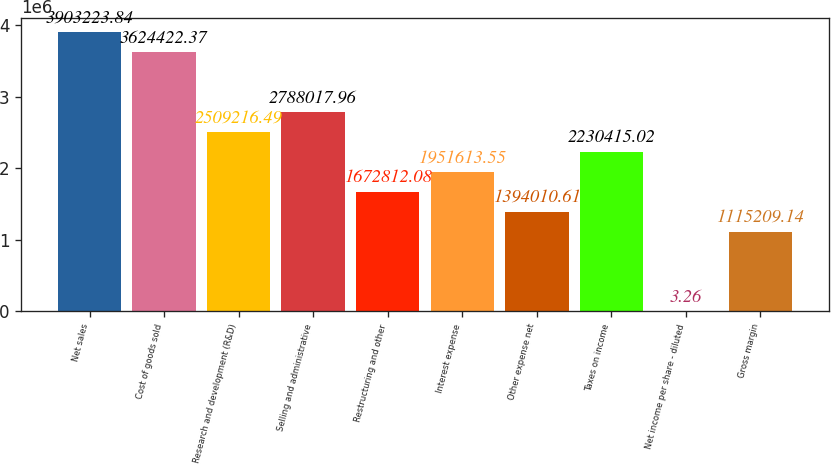<chart> <loc_0><loc_0><loc_500><loc_500><bar_chart><fcel>Net sales<fcel>Cost of goods sold<fcel>Research and development (R&D)<fcel>Selling and administrative<fcel>Restructuring and other<fcel>Interest expense<fcel>Other expense net<fcel>Taxes on income<fcel>Net income per share - diluted<fcel>Gross margin<nl><fcel>3.90322e+06<fcel>3.62442e+06<fcel>2.50922e+06<fcel>2.78802e+06<fcel>1.67281e+06<fcel>1.95161e+06<fcel>1.39401e+06<fcel>2.23042e+06<fcel>3.26<fcel>1.11521e+06<nl></chart> 